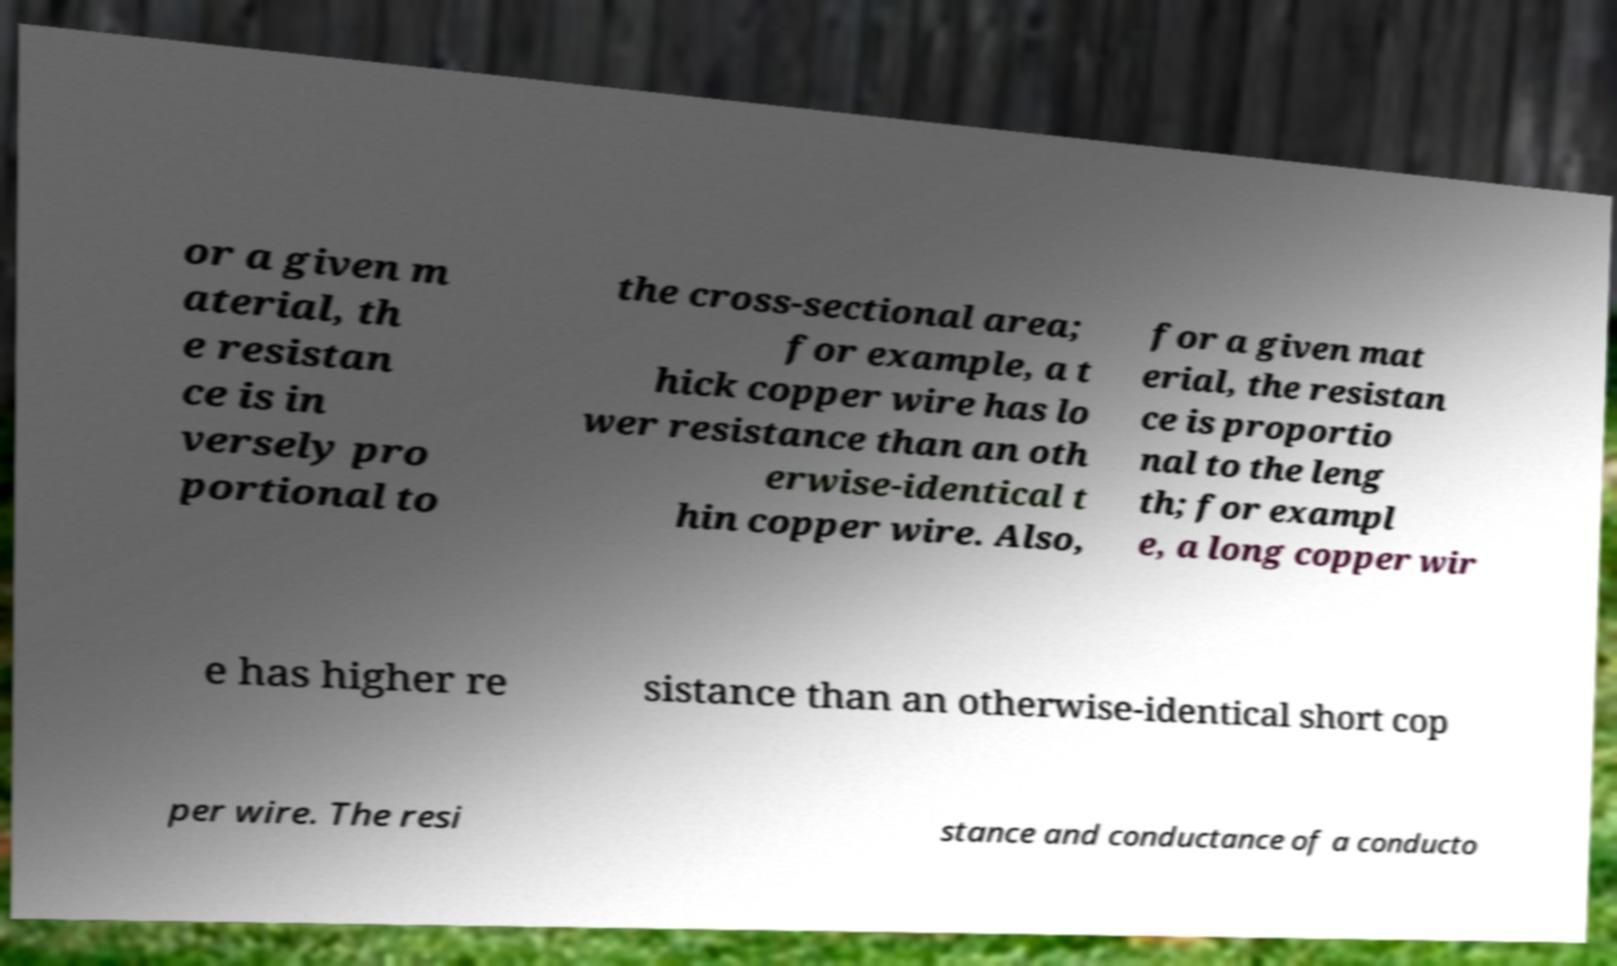Could you extract and type out the text from this image? or a given m aterial, th e resistan ce is in versely pro portional to the cross-sectional area; for example, a t hick copper wire has lo wer resistance than an oth erwise-identical t hin copper wire. Also, for a given mat erial, the resistan ce is proportio nal to the leng th; for exampl e, a long copper wir e has higher re sistance than an otherwise-identical short cop per wire. The resi stance and conductance of a conducto 